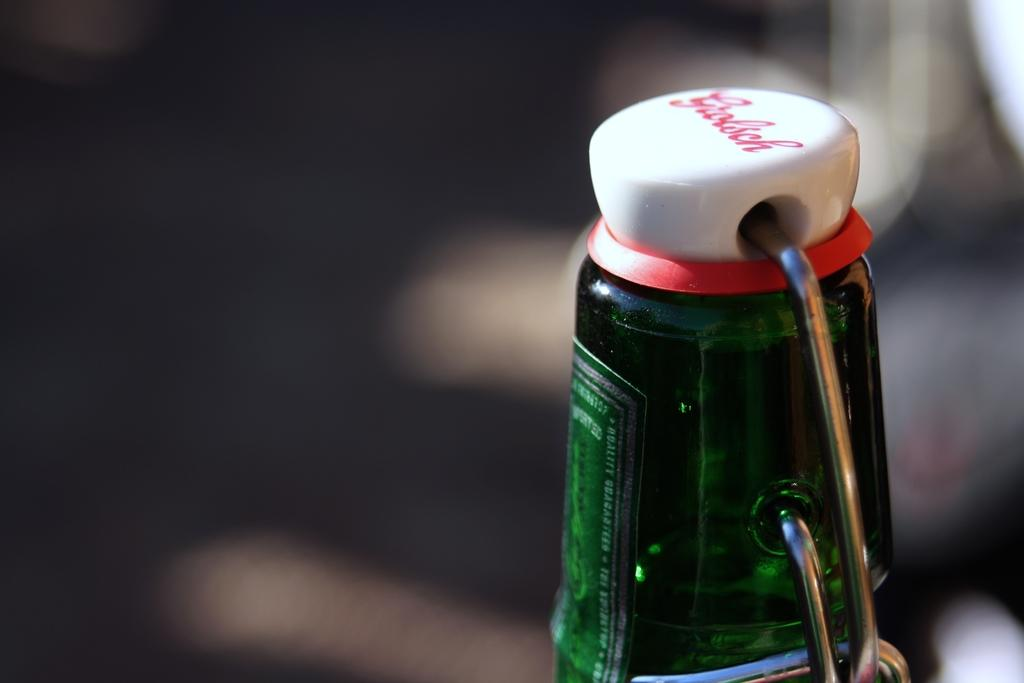What is the color of the bottle in the image? The bottle in the image is green in color. What is on the bottle? The bottle has a sticker on it. What is covering the opening of the bottle? There is a cap on the bottle. What color is the cap? The cap is white in color. What is written on the cap? The cap has red color writings on it. How many boats are visible in the image? There are no boats present in the image. What type of bird can be seen perched on the bottle in the image? There are no birds, including wrens, present in the image. 